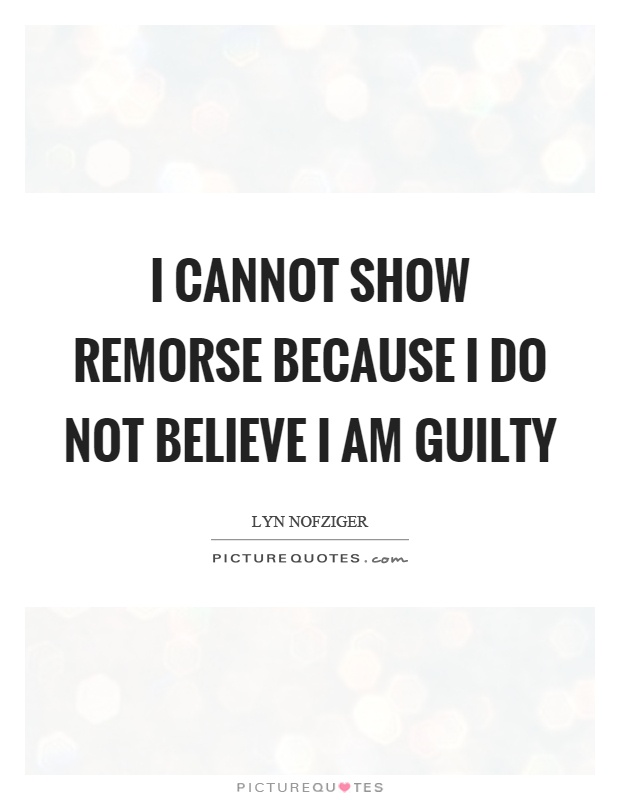Based on the style and presentation of the quote in the image, what can we infer about the intended audience or use of this image? Based on the style and presentation of the quote, which includes a professional-looking, clean sans-serif font and a sophisticated, subdued background, we can infer that the image is likely designed for a general audience with the purpose of conveying a reflective or thought-provoking message. The citation of "picturequotes.com" suggests that it is meant for online sharing, possibly on social media or for use in personal blogs and websites where inspirational or contemplative quotes are appreciated. 